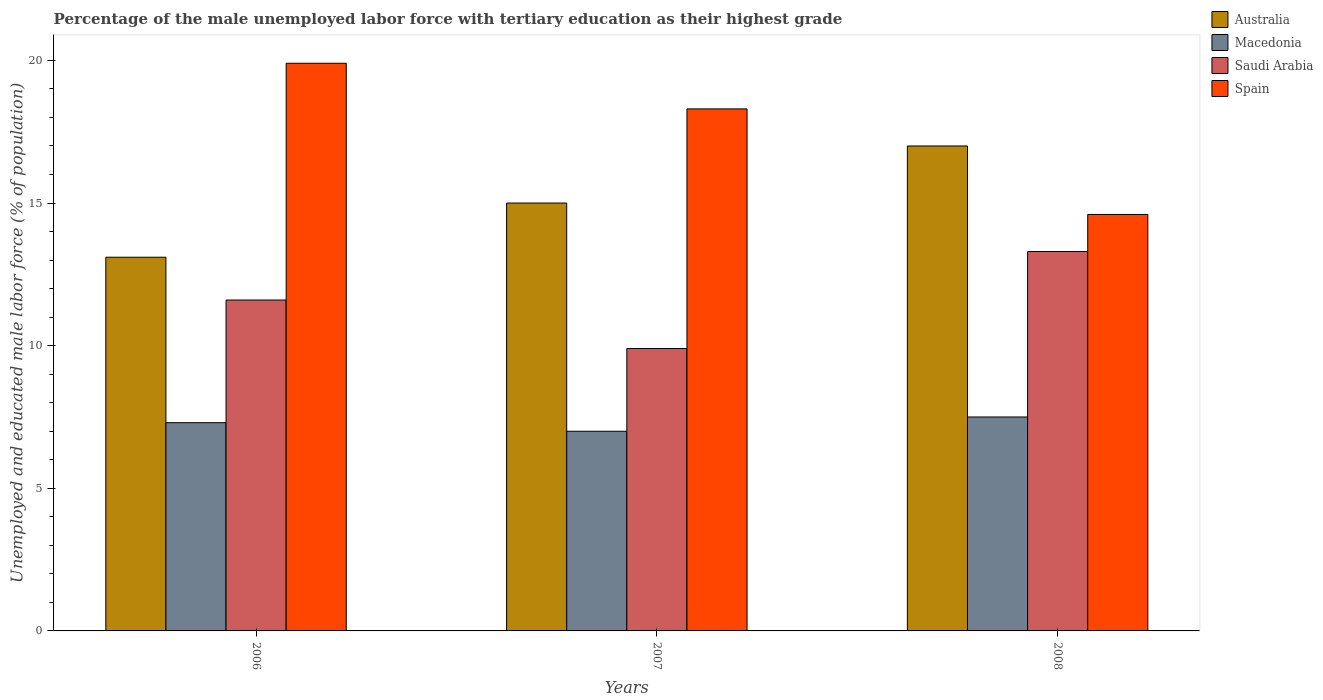How many different coloured bars are there?
Make the answer very short. 4. Are the number of bars on each tick of the X-axis equal?
Provide a short and direct response. Yes. How many bars are there on the 1st tick from the left?
Provide a succinct answer. 4. What is the label of the 2nd group of bars from the left?
Your answer should be compact. 2007. What is the percentage of the unemployed male labor force with tertiary education in Spain in 2007?
Ensure brevity in your answer.  18.3. Across all years, what is the maximum percentage of the unemployed male labor force with tertiary education in Australia?
Offer a very short reply. 17. Across all years, what is the minimum percentage of the unemployed male labor force with tertiary education in Saudi Arabia?
Offer a very short reply. 9.9. What is the total percentage of the unemployed male labor force with tertiary education in Macedonia in the graph?
Keep it short and to the point. 21.8. What is the difference between the percentage of the unemployed male labor force with tertiary education in Saudi Arabia in 2007 and that in 2008?
Give a very brief answer. -3.4. What is the difference between the percentage of the unemployed male labor force with tertiary education in Macedonia in 2007 and the percentage of the unemployed male labor force with tertiary education in Saudi Arabia in 2008?
Your answer should be very brief. -6.3. What is the average percentage of the unemployed male labor force with tertiary education in Saudi Arabia per year?
Offer a terse response. 11.6. In the year 2008, what is the difference between the percentage of the unemployed male labor force with tertiary education in Spain and percentage of the unemployed male labor force with tertiary education in Macedonia?
Your response must be concise. 7.1. What is the ratio of the percentage of the unemployed male labor force with tertiary education in Australia in 2006 to that in 2007?
Keep it short and to the point. 0.87. Is the percentage of the unemployed male labor force with tertiary education in Spain in 2006 less than that in 2008?
Make the answer very short. No. Is the difference between the percentage of the unemployed male labor force with tertiary education in Spain in 2007 and 2008 greater than the difference between the percentage of the unemployed male labor force with tertiary education in Macedonia in 2007 and 2008?
Your answer should be compact. Yes. What is the difference between the highest and the second highest percentage of the unemployed male labor force with tertiary education in Spain?
Your response must be concise. 1.6. What is the difference between the highest and the lowest percentage of the unemployed male labor force with tertiary education in Australia?
Your answer should be very brief. 3.9. In how many years, is the percentage of the unemployed male labor force with tertiary education in Saudi Arabia greater than the average percentage of the unemployed male labor force with tertiary education in Saudi Arabia taken over all years?
Keep it short and to the point. 2. Is the sum of the percentage of the unemployed male labor force with tertiary education in Spain in 2007 and 2008 greater than the maximum percentage of the unemployed male labor force with tertiary education in Macedonia across all years?
Make the answer very short. Yes. Is it the case that in every year, the sum of the percentage of the unemployed male labor force with tertiary education in Macedonia and percentage of the unemployed male labor force with tertiary education in Australia is greater than the sum of percentage of the unemployed male labor force with tertiary education in Saudi Arabia and percentage of the unemployed male labor force with tertiary education in Spain?
Keep it short and to the point. Yes. How many bars are there?
Provide a succinct answer. 12. Are all the bars in the graph horizontal?
Your answer should be compact. No. How many years are there in the graph?
Give a very brief answer. 3. What is the difference between two consecutive major ticks on the Y-axis?
Your answer should be compact. 5. Are the values on the major ticks of Y-axis written in scientific E-notation?
Your answer should be compact. No. Does the graph contain any zero values?
Your answer should be very brief. No. Does the graph contain grids?
Keep it short and to the point. No. How many legend labels are there?
Offer a terse response. 4. How are the legend labels stacked?
Ensure brevity in your answer.  Vertical. What is the title of the graph?
Provide a short and direct response. Percentage of the male unemployed labor force with tertiary education as their highest grade. Does "Ecuador" appear as one of the legend labels in the graph?
Keep it short and to the point. No. What is the label or title of the X-axis?
Ensure brevity in your answer.  Years. What is the label or title of the Y-axis?
Your response must be concise. Unemployed and educated male labor force (% of population). What is the Unemployed and educated male labor force (% of population) in Australia in 2006?
Your response must be concise. 13.1. What is the Unemployed and educated male labor force (% of population) of Macedonia in 2006?
Make the answer very short. 7.3. What is the Unemployed and educated male labor force (% of population) of Saudi Arabia in 2006?
Offer a very short reply. 11.6. What is the Unemployed and educated male labor force (% of population) of Spain in 2006?
Your response must be concise. 19.9. What is the Unemployed and educated male labor force (% of population) of Australia in 2007?
Offer a terse response. 15. What is the Unemployed and educated male labor force (% of population) in Macedonia in 2007?
Your answer should be compact. 7. What is the Unemployed and educated male labor force (% of population) of Saudi Arabia in 2007?
Keep it short and to the point. 9.9. What is the Unemployed and educated male labor force (% of population) in Spain in 2007?
Provide a succinct answer. 18.3. What is the Unemployed and educated male labor force (% of population) of Australia in 2008?
Your answer should be very brief. 17. What is the Unemployed and educated male labor force (% of population) of Macedonia in 2008?
Provide a succinct answer. 7.5. What is the Unemployed and educated male labor force (% of population) in Saudi Arabia in 2008?
Your response must be concise. 13.3. What is the Unemployed and educated male labor force (% of population) of Spain in 2008?
Make the answer very short. 14.6. Across all years, what is the maximum Unemployed and educated male labor force (% of population) in Australia?
Offer a terse response. 17. Across all years, what is the maximum Unemployed and educated male labor force (% of population) of Macedonia?
Your answer should be very brief. 7.5. Across all years, what is the maximum Unemployed and educated male labor force (% of population) of Saudi Arabia?
Offer a terse response. 13.3. Across all years, what is the maximum Unemployed and educated male labor force (% of population) in Spain?
Ensure brevity in your answer.  19.9. Across all years, what is the minimum Unemployed and educated male labor force (% of population) of Australia?
Provide a short and direct response. 13.1. Across all years, what is the minimum Unemployed and educated male labor force (% of population) of Saudi Arabia?
Keep it short and to the point. 9.9. Across all years, what is the minimum Unemployed and educated male labor force (% of population) in Spain?
Offer a very short reply. 14.6. What is the total Unemployed and educated male labor force (% of population) of Australia in the graph?
Keep it short and to the point. 45.1. What is the total Unemployed and educated male labor force (% of population) in Macedonia in the graph?
Offer a terse response. 21.8. What is the total Unemployed and educated male labor force (% of population) in Saudi Arabia in the graph?
Provide a succinct answer. 34.8. What is the total Unemployed and educated male labor force (% of population) in Spain in the graph?
Provide a short and direct response. 52.8. What is the difference between the Unemployed and educated male labor force (% of population) of Australia in 2006 and that in 2007?
Offer a terse response. -1.9. What is the difference between the Unemployed and educated male labor force (% of population) of Macedonia in 2006 and that in 2007?
Give a very brief answer. 0.3. What is the difference between the Unemployed and educated male labor force (% of population) of Spain in 2006 and that in 2007?
Your response must be concise. 1.6. What is the difference between the Unemployed and educated male labor force (% of population) of Australia in 2006 and that in 2008?
Provide a succinct answer. -3.9. What is the difference between the Unemployed and educated male labor force (% of population) in Spain in 2006 and that in 2008?
Ensure brevity in your answer.  5.3. What is the difference between the Unemployed and educated male labor force (% of population) in Macedonia in 2007 and that in 2008?
Offer a very short reply. -0.5. What is the difference between the Unemployed and educated male labor force (% of population) of Australia in 2006 and the Unemployed and educated male labor force (% of population) of Macedonia in 2007?
Your response must be concise. 6.1. What is the difference between the Unemployed and educated male labor force (% of population) in Macedonia in 2006 and the Unemployed and educated male labor force (% of population) in Saudi Arabia in 2007?
Your answer should be very brief. -2.6. What is the difference between the Unemployed and educated male labor force (% of population) in Macedonia in 2006 and the Unemployed and educated male labor force (% of population) in Spain in 2007?
Provide a succinct answer. -11. What is the difference between the Unemployed and educated male labor force (% of population) in Saudi Arabia in 2006 and the Unemployed and educated male labor force (% of population) in Spain in 2007?
Make the answer very short. -6.7. What is the difference between the Unemployed and educated male labor force (% of population) of Australia in 2006 and the Unemployed and educated male labor force (% of population) of Macedonia in 2008?
Provide a short and direct response. 5.6. What is the difference between the Unemployed and educated male labor force (% of population) of Australia in 2006 and the Unemployed and educated male labor force (% of population) of Spain in 2008?
Offer a very short reply. -1.5. What is the difference between the Unemployed and educated male labor force (% of population) of Macedonia in 2006 and the Unemployed and educated male labor force (% of population) of Saudi Arabia in 2008?
Ensure brevity in your answer.  -6. What is the difference between the Unemployed and educated male labor force (% of population) of Australia in 2007 and the Unemployed and educated male labor force (% of population) of Macedonia in 2008?
Provide a succinct answer. 7.5. What is the difference between the Unemployed and educated male labor force (% of population) in Australia in 2007 and the Unemployed and educated male labor force (% of population) in Saudi Arabia in 2008?
Your response must be concise. 1.7. What is the difference between the Unemployed and educated male labor force (% of population) of Australia in 2007 and the Unemployed and educated male labor force (% of population) of Spain in 2008?
Provide a short and direct response. 0.4. What is the average Unemployed and educated male labor force (% of population) in Australia per year?
Your answer should be compact. 15.03. What is the average Unemployed and educated male labor force (% of population) in Macedonia per year?
Give a very brief answer. 7.27. In the year 2006, what is the difference between the Unemployed and educated male labor force (% of population) of Australia and Unemployed and educated male labor force (% of population) of Saudi Arabia?
Ensure brevity in your answer.  1.5. In the year 2007, what is the difference between the Unemployed and educated male labor force (% of population) in Australia and Unemployed and educated male labor force (% of population) in Macedonia?
Make the answer very short. 8. In the year 2007, what is the difference between the Unemployed and educated male labor force (% of population) in Macedonia and Unemployed and educated male labor force (% of population) in Spain?
Offer a terse response. -11.3. In the year 2007, what is the difference between the Unemployed and educated male labor force (% of population) in Saudi Arabia and Unemployed and educated male labor force (% of population) in Spain?
Offer a terse response. -8.4. In the year 2008, what is the difference between the Unemployed and educated male labor force (% of population) of Australia and Unemployed and educated male labor force (% of population) of Macedonia?
Keep it short and to the point. 9.5. In the year 2008, what is the difference between the Unemployed and educated male labor force (% of population) of Australia and Unemployed and educated male labor force (% of population) of Spain?
Your answer should be compact. 2.4. In the year 2008, what is the difference between the Unemployed and educated male labor force (% of population) of Macedonia and Unemployed and educated male labor force (% of population) of Spain?
Offer a very short reply. -7.1. In the year 2008, what is the difference between the Unemployed and educated male labor force (% of population) in Saudi Arabia and Unemployed and educated male labor force (% of population) in Spain?
Provide a succinct answer. -1.3. What is the ratio of the Unemployed and educated male labor force (% of population) of Australia in 2006 to that in 2007?
Offer a terse response. 0.87. What is the ratio of the Unemployed and educated male labor force (% of population) of Macedonia in 2006 to that in 2007?
Your answer should be very brief. 1.04. What is the ratio of the Unemployed and educated male labor force (% of population) in Saudi Arabia in 2006 to that in 2007?
Give a very brief answer. 1.17. What is the ratio of the Unemployed and educated male labor force (% of population) in Spain in 2006 to that in 2007?
Your answer should be very brief. 1.09. What is the ratio of the Unemployed and educated male labor force (% of population) of Australia in 2006 to that in 2008?
Your answer should be compact. 0.77. What is the ratio of the Unemployed and educated male labor force (% of population) of Macedonia in 2006 to that in 2008?
Keep it short and to the point. 0.97. What is the ratio of the Unemployed and educated male labor force (% of population) of Saudi Arabia in 2006 to that in 2008?
Make the answer very short. 0.87. What is the ratio of the Unemployed and educated male labor force (% of population) of Spain in 2006 to that in 2008?
Ensure brevity in your answer.  1.36. What is the ratio of the Unemployed and educated male labor force (% of population) in Australia in 2007 to that in 2008?
Your answer should be very brief. 0.88. What is the ratio of the Unemployed and educated male labor force (% of population) in Macedonia in 2007 to that in 2008?
Provide a succinct answer. 0.93. What is the ratio of the Unemployed and educated male labor force (% of population) of Saudi Arabia in 2007 to that in 2008?
Keep it short and to the point. 0.74. What is the ratio of the Unemployed and educated male labor force (% of population) of Spain in 2007 to that in 2008?
Keep it short and to the point. 1.25. What is the difference between the highest and the second highest Unemployed and educated male labor force (% of population) of Australia?
Keep it short and to the point. 2. What is the difference between the highest and the second highest Unemployed and educated male labor force (% of population) in Macedonia?
Make the answer very short. 0.2. What is the difference between the highest and the second highest Unemployed and educated male labor force (% of population) in Saudi Arabia?
Your response must be concise. 1.7. What is the difference between the highest and the lowest Unemployed and educated male labor force (% of population) in Spain?
Keep it short and to the point. 5.3. 